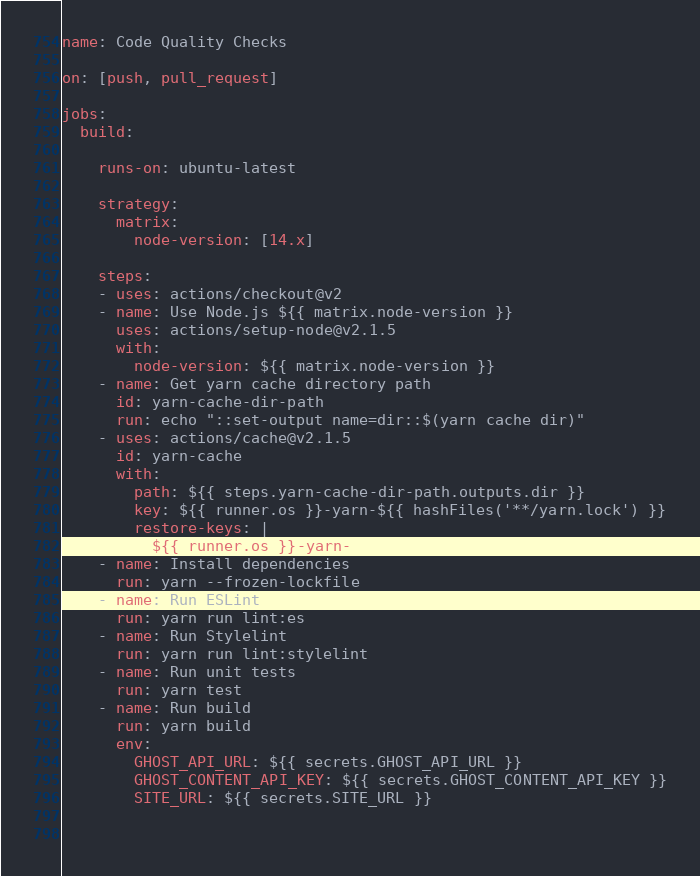Convert code to text. <code><loc_0><loc_0><loc_500><loc_500><_YAML_>name: Code Quality Checks

on: [push, pull_request]

jobs:
  build:

    runs-on: ubuntu-latest

    strategy:
      matrix:
        node-version: [14.x]

    steps:
    - uses: actions/checkout@v2
    - name: Use Node.js ${{ matrix.node-version }}
      uses: actions/setup-node@v2.1.5
      with:
        node-version: ${{ matrix.node-version }}
    - name: Get yarn cache directory path
      id: yarn-cache-dir-path
      run: echo "::set-output name=dir::$(yarn cache dir)"
    - uses: actions/cache@v2.1.5
      id: yarn-cache
      with:
        path: ${{ steps.yarn-cache-dir-path.outputs.dir }}
        key: ${{ runner.os }}-yarn-${{ hashFiles('**/yarn.lock') }}
        restore-keys: |
          ${{ runner.os }}-yarn-
    - name: Install dependencies
      run: yarn --frozen-lockfile
    - name: Run ESLint
      run: yarn run lint:es
    - name: Run Stylelint
      run: yarn run lint:stylelint
    - name: Run unit tests
      run: yarn test
    - name: Run build
      run: yarn build
      env:
        GHOST_API_URL: ${{ secrets.GHOST_API_URL }}
        GHOST_CONTENT_API_KEY: ${{ secrets.GHOST_CONTENT_API_KEY }}
        SITE_URL: ${{ secrets.SITE_URL }}
      
  
</code> 